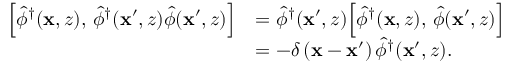<formula> <loc_0><loc_0><loc_500><loc_500>\begin{array} { r l } { \left [ \hat { \phi } ^ { \dagger } ( x , z ) , \, \hat { \phi } ^ { \dagger } ( x ^ { \prime } , z ) \hat { \phi } ( x ^ { \prime } , z ) \right ] } & { = \hat { \phi } ^ { \dagger } ( x ^ { \prime } , z ) \left [ \hat { \phi } ^ { \dagger } ( x , z ) , \, \hat { \phi } ( x ^ { \prime } , z ) \right ] } \\ & { = - \delta \left ( x - x ^ { \prime } \right ) \hat { \phi } ^ { \dagger } ( x ^ { \prime } , z ) . } \end{array}</formula> 